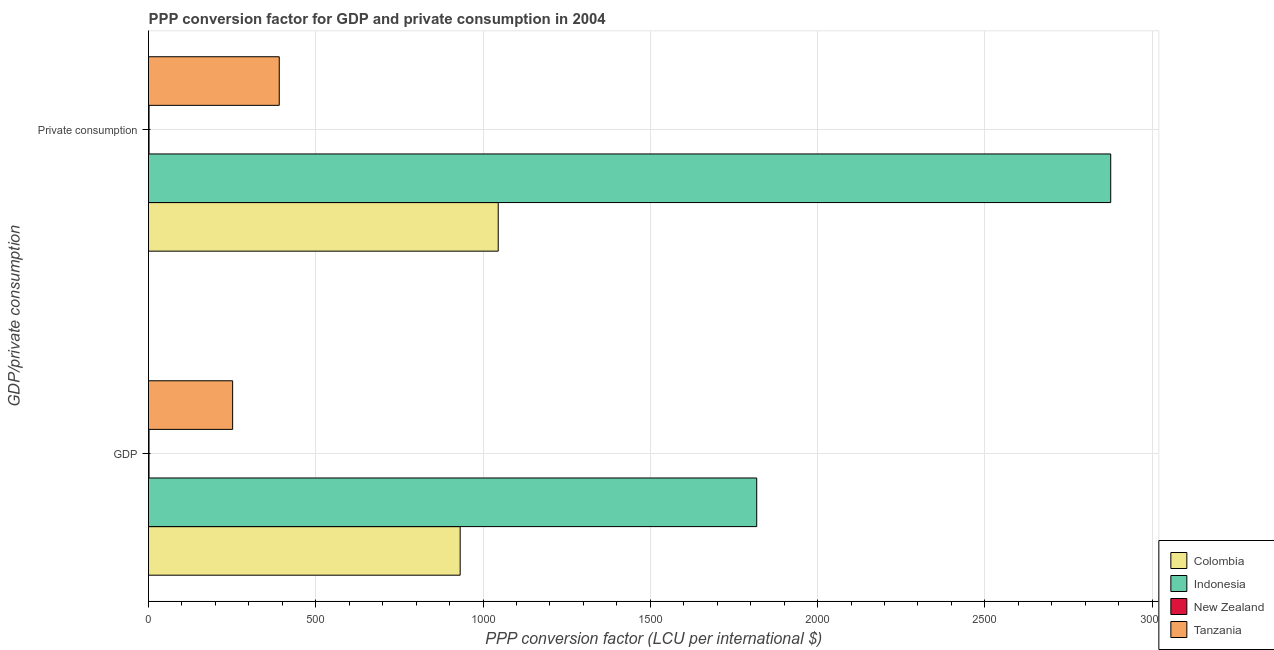How many groups of bars are there?
Your response must be concise. 2. How many bars are there on the 2nd tick from the top?
Provide a short and direct response. 4. How many bars are there on the 1st tick from the bottom?
Your answer should be compact. 4. What is the label of the 1st group of bars from the top?
Provide a succinct answer.  Private consumption. What is the ppp conversion factor for private consumption in Indonesia?
Give a very brief answer. 2876.24. Across all countries, what is the maximum ppp conversion factor for private consumption?
Give a very brief answer. 2876.24. Across all countries, what is the minimum ppp conversion factor for private consumption?
Your response must be concise. 1.57. In which country was the ppp conversion factor for private consumption maximum?
Provide a short and direct response. Indonesia. In which country was the ppp conversion factor for private consumption minimum?
Your answer should be very brief. New Zealand. What is the total ppp conversion factor for private consumption in the graph?
Your response must be concise. 4313.91. What is the difference between the ppp conversion factor for private consumption in Colombia and that in New Zealand?
Your answer should be compact. 1043.77. What is the difference between the ppp conversion factor for gdp in Tanzania and the ppp conversion factor for private consumption in New Zealand?
Your answer should be very brief. 249.89. What is the average ppp conversion factor for gdp per country?
Provide a short and direct response. 750.65. What is the difference between the ppp conversion factor for gdp and ppp conversion factor for private consumption in New Zealand?
Ensure brevity in your answer.  -0.06. What is the ratio of the ppp conversion factor for gdp in New Zealand to that in Indonesia?
Provide a succinct answer. 0. Is the ppp conversion factor for gdp in Indonesia less than that in Colombia?
Your answer should be very brief. No. In how many countries, is the ppp conversion factor for private consumption greater than the average ppp conversion factor for private consumption taken over all countries?
Your answer should be very brief. 1. What does the 1st bar from the top in  Private consumption represents?
Your answer should be compact. Tanzania. How many bars are there?
Provide a succinct answer. 8. Are all the bars in the graph horizontal?
Ensure brevity in your answer.  Yes. How many countries are there in the graph?
Offer a very short reply. 4. What is the difference between two consecutive major ticks on the X-axis?
Ensure brevity in your answer.  500. Does the graph contain any zero values?
Your answer should be compact. No. Where does the legend appear in the graph?
Your answer should be compact. Bottom right. What is the title of the graph?
Provide a succinct answer. PPP conversion factor for GDP and private consumption in 2004. Does "Jamaica" appear as one of the legend labels in the graph?
Ensure brevity in your answer.  No. What is the label or title of the X-axis?
Keep it short and to the point. PPP conversion factor (LCU per international $). What is the label or title of the Y-axis?
Offer a very short reply. GDP/private consumption. What is the PPP conversion factor (LCU per international $) of Colombia in GDP?
Your response must be concise. 931.6. What is the PPP conversion factor (LCU per international $) of Indonesia in GDP?
Your response must be concise. 1818.04. What is the PPP conversion factor (LCU per international $) in New Zealand in GDP?
Ensure brevity in your answer.  1.51. What is the PPP conversion factor (LCU per international $) of Tanzania in GDP?
Make the answer very short. 251.46. What is the PPP conversion factor (LCU per international $) in Colombia in  Private consumption?
Provide a succinct answer. 1045.33. What is the PPP conversion factor (LCU per international $) of Indonesia in  Private consumption?
Make the answer very short. 2876.24. What is the PPP conversion factor (LCU per international $) of New Zealand in  Private consumption?
Your answer should be very brief. 1.57. What is the PPP conversion factor (LCU per international $) of Tanzania in  Private consumption?
Provide a succinct answer. 390.77. Across all GDP/private consumption, what is the maximum PPP conversion factor (LCU per international $) in Colombia?
Give a very brief answer. 1045.33. Across all GDP/private consumption, what is the maximum PPP conversion factor (LCU per international $) in Indonesia?
Give a very brief answer. 2876.24. Across all GDP/private consumption, what is the maximum PPP conversion factor (LCU per international $) in New Zealand?
Offer a very short reply. 1.57. Across all GDP/private consumption, what is the maximum PPP conversion factor (LCU per international $) in Tanzania?
Your answer should be compact. 390.77. Across all GDP/private consumption, what is the minimum PPP conversion factor (LCU per international $) of Colombia?
Give a very brief answer. 931.6. Across all GDP/private consumption, what is the minimum PPP conversion factor (LCU per international $) of Indonesia?
Give a very brief answer. 1818.04. Across all GDP/private consumption, what is the minimum PPP conversion factor (LCU per international $) of New Zealand?
Provide a short and direct response. 1.51. Across all GDP/private consumption, what is the minimum PPP conversion factor (LCU per international $) of Tanzania?
Offer a very short reply. 251.46. What is the total PPP conversion factor (LCU per international $) of Colombia in the graph?
Make the answer very short. 1976.94. What is the total PPP conversion factor (LCU per international $) of Indonesia in the graph?
Keep it short and to the point. 4694.28. What is the total PPP conversion factor (LCU per international $) in New Zealand in the graph?
Offer a very short reply. 3.07. What is the total PPP conversion factor (LCU per international $) of Tanzania in the graph?
Provide a short and direct response. 642.22. What is the difference between the PPP conversion factor (LCU per international $) in Colombia in GDP and that in  Private consumption?
Ensure brevity in your answer.  -113.73. What is the difference between the PPP conversion factor (LCU per international $) in Indonesia in GDP and that in  Private consumption?
Your answer should be compact. -1058.21. What is the difference between the PPP conversion factor (LCU per international $) of New Zealand in GDP and that in  Private consumption?
Ensure brevity in your answer.  -0.06. What is the difference between the PPP conversion factor (LCU per international $) of Tanzania in GDP and that in  Private consumption?
Your answer should be very brief. -139.31. What is the difference between the PPP conversion factor (LCU per international $) in Colombia in GDP and the PPP conversion factor (LCU per international $) in Indonesia in  Private consumption?
Ensure brevity in your answer.  -1944.64. What is the difference between the PPP conversion factor (LCU per international $) of Colombia in GDP and the PPP conversion factor (LCU per international $) of New Zealand in  Private consumption?
Ensure brevity in your answer.  930.04. What is the difference between the PPP conversion factor (LCU per international $) in Colombia in GDP and the PPP conversion factor (LCU per international $) in Tanzania in  Private consumption?
Ensure brevity in your answer.  540.84. What is the difference between the PPP conversion factor (LCU per international $) of Indonesia in GDP and the PPP conversion factor (LCU per international $) of New Zealand in  Private consumption?
Make the answer very short. 1816.47. What is the difference between the PPP conversion factor (LCU per international $) in Indonesia in GDP and the PPP conversion factor (LCU per international $) in Tanzania in  Private consumption?
Provide a succinct answer. 1427.27. What is the difference between the PPP conversion factor (LCU per international $) in New Zealand in GDP and the PPP conversion factor (LCU per international $) in Tanzania in  Private consumption?
Ensure brevity in your answer.  -389.26. What is the average PPP conversion factor (LCU per international $) of Colombia per GDP/private consumption?
Make the answer very short. 988.47. What is the average PPP conversion factor (LCU per international $) in Indonesia per GDP/private consumption?
Your response must be concise. 2347.14. What is the average PPP conversion factor (LCU per international $) in New Zealand per GDP/private consumption?
Provide a short and direct response. 1.54. What is the average PPP conversion factor (LCU per international $) in Tanzania per GDP/private consumption?
Offer a very short reply. 321.11. What is the difference between the PPP conversion factor (LCU per international $) of Colombia and PPP conversion factor (LCU per international $) of Indonesia in GDP?
Your response must be concise. -886.43. What is the difference between the PPP conversion factor (LCU per international $) in Colombia and PPP conversion factor (LCU per international $) in New Zealand in GDP?
Give a very brief answer. 930.1. What is the difference between the PPP conversion factor (LCU per international $) of Colombia and PPP conversion factor (LCU per international $) of Tanzania in GDP?
Your response must be concise. 680.15. What is the difference between the PPP conversion factor (LCU per international $) of Indonesia and PPP conversion factor (LCU per international $) of New Zealand in GDP?
Offer a terse response. 1816.53. What is the difference between the PPP conversion factor (LCU per international $) of Indonesia and PPP conversion factor (LCU per international $) of Tanzania in GDP?
Your response must be concise. 1566.58. What is the difference between the PPP conversion factor (LCU per international $) in New Zealand and PPP conversion factor (LCU per international $) in Tanzania in GDP?
Keep it short and to the point. -249.95. What is the difference between the PPP conversion factor (LCU per international $) in Colombia and PPP conversion factor (LCU per international $) in Indonesia in  Private consumption?
Your answer should be very brief. -1830.91. What is the difference between the PPP conversion factor (LCU per international $) of Colombia and PPP conversion factor (LCU per international $) of New Zealand in  Private consumption?
Give a very brief answer. 1043.77. What is the difference between the PPP conversion factor (LCU per international $) in Colombia and PPP conversion factor (LCU per international $) in Tanzania in  Private consumption?
Make the answer very short. 654.57. What is the difference between the PPP conversion factor (LCU per international $) of Indonesia and PPP conversion factor (LCU per international $) of New Zealand in  Private consumption?
Give a very brief answer. 2874.68. What is the difference between the PPP conversion factor (LCU per international $) in Indonesia and PPP conversion factor (LCU per international $) in Tanzania in  Private consumption?
Your response must be concise. 2485.48. What is the difference between the PPP conversion factor (LCU per international $) in New Zealand and PPP conversion factor (LCU per international $) in Tanzania in  Private consumption?
Make the answer very short. -389.2. What is the ratio of the PPP conversion factor (LCU per international $) of Colombia in GDP to that in  Private consumption?
Provide a succinct answer. 0.89. What is the ratio of the PPP conversion factor (LCU per international $) of Indonesia in GDP to that in  Private consumption?
Give a very brief answer. 0.63. What is the ratio of the PPP conversion factor (LCU per international $) of New Zealand in GDP to that in  Private consumption?
Make the answer very short. 0.96. What is the ratio of the PPP conversion factor (LCU per international $) of Tanzania in GDP to that in  Private consumption?
Make the answer very short. 0.64. What is the difference between the highest and the second highest PPP conversion factor (LCU per international $) of Colombia?
Your answer should be compact. 113.73. What is the difference between the highest and the second highest PPP conversion factor (LCU per international $) of Indonesia?
Your response must be concise. 1058.21. What is the difference between the highest and the second highest PPP conversion factor (LCU per international $) of New Zealand?
Offer a very short reply. 0.06. What is the difference between the highest and the second highest PPP conversion factor (LCU per international $) in Tanzania?
Your answer should be compact. 139.31. What is the difference between the highest and the lowest PPP conversion factor (LCU per international $) of Colombia?
Provide a short and direct response. 113.73. What is the difference between the highest and the lowest PPP conversion factor (LCU per international $) of Indonesia?
Your answer should be very brief. 1058.21. What is the difference between the highest and the lowest PPP conversion factor (LCU per international $) in New Zealand?
Your answer should be very brief. 0.06. What is the difference between the highest and the lowest PPP conversion factor (LCU per international $) in Tanzania?
Provide a succinct answer. 139.31. 